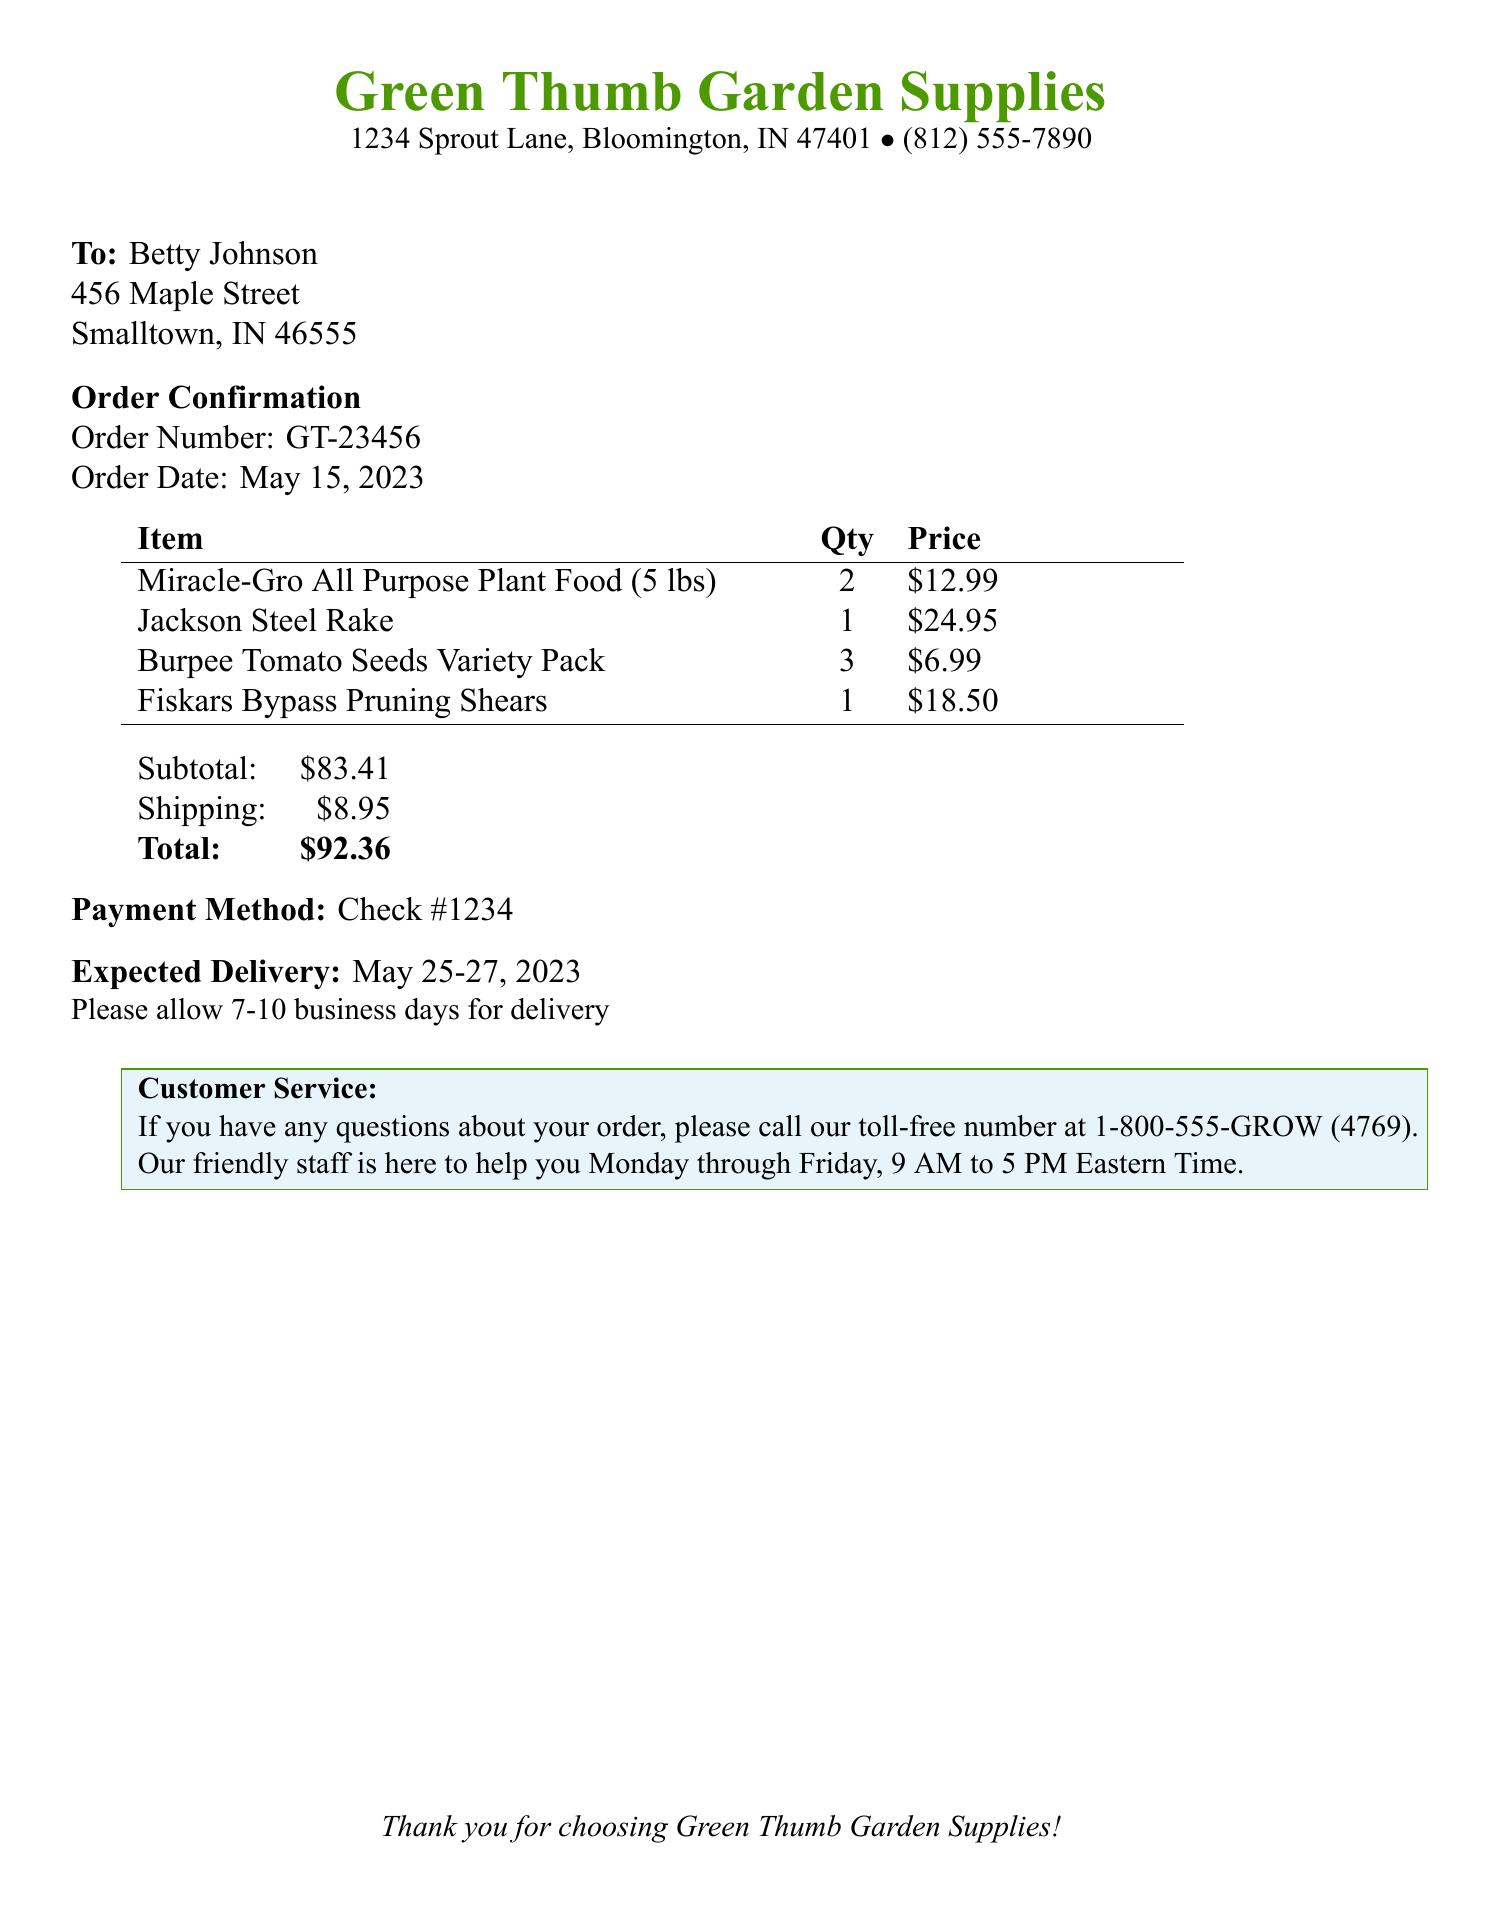What is the order number? The order number is mentioned under the order confirmation section as GT-23456.
Answer: GT-23456 What is the total price of the order? The total price is specified at the end of the document under the total section as $92.36.
Answer: $92.36 What is the expected delivery date? The expected delivery date is listed in the document as May 25-27, 2023.
Answer: May 25-27, 2023 How many Burpee Tomato Seeds Variety Packs were ordered? The quantity of Burpee Tomato Seeds Variety Packs is noted in the itemized list as 3.
Answer: 3 What method of payment was used? The payment method is identified in the document as Check #1234.
Answer: Check #1234 What is the subtotal before shipping? The subtotal is given just before the shipping charge as $83.41.
Answer: $83.41 Who is the order addressed to? The order is addressed to Betty Johnson, as noted near the top of the document.
Answer: Betty Johnson What is the phone number for customer service? The customer service number is provided in the document as 1-800-555-GROW (4769).
Answer: 1-800-555-GROW (4769) 